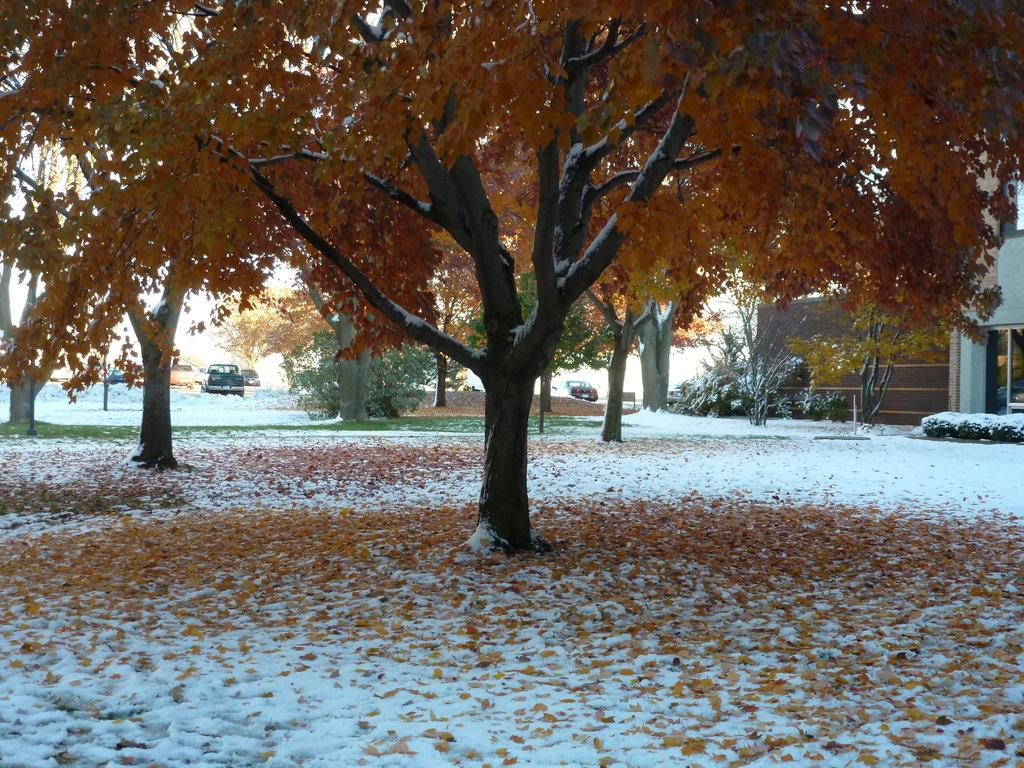What is on the ground in the image? There are dry leaves on the ground in the image. What can be seen in the background of the image? There are trees, vehicles, and a house in the background of the image. What type of silverware is being used by the brothers in the image? There are no brothers or silverware present in the image. 